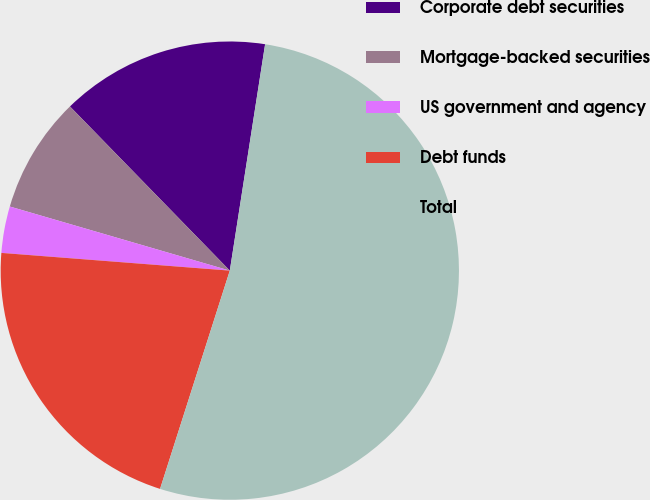<chart> <loc_0><loc_0><loc_500><loc_500><pie_chart><fcel>Corporate debt securities<fcel>Mortgage-backed securities<fcel>US government and agency<fcel>Debt funds<fcel>Total<nl><fcel>14.75%<fcel>8.2%<fcel>3.28%<fcel>21.31%<fcel>52.46%<nl></chart> 